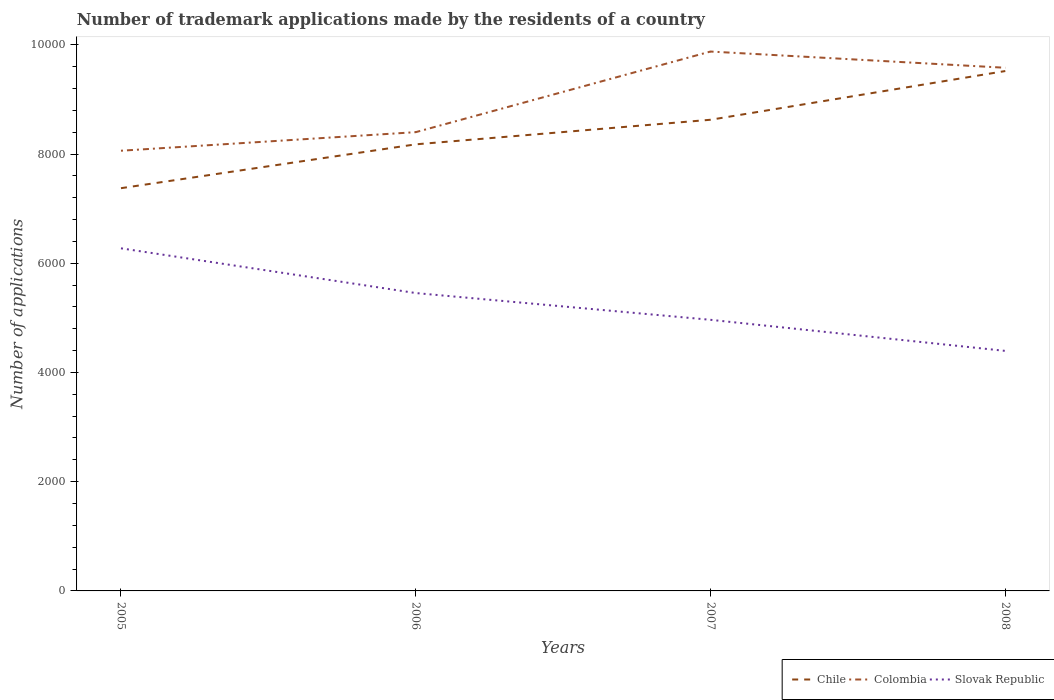Is the number of lines equal to the number of legend labels?
Your answer should be compact. Yes. Across all years, what is the maximum number of trademark applications made by the residents in Chile?
Keep it short and to the point. 7374. In which year was the number of trademark applications made by the residents in Colombia maximum?
Offer a terse response. 2005. What is the total number of trademark applications made by the residents in Chile in the graph?
Your response must be concise. -1342. What is the difference between the highest and the second highest number of trademark applications made by the residents in Colombia?
Give a very brief answer. 1816. What is the difference between the highest and the lowest number of trademark applications made by the residents in Colombia?
Provide a short and direct response. 2. Is the number of trademark applications made by the residents in Chile strictly greater than the number of trademark applications made by the residents in Slovak Republic over the years?
Give a very brief answer. No. What is the difference between two consecutive major ticks on the Y-axis?
Make the answer very short. 2000. Are the values on the major ticks of Y-axis written in scientific E-notation?
Make the answer very short. No. Does the graph contain any zero values?
Make the answer very short. No. Does the graph contain grids?
Your answer should be very brief. No. What is the title of the graph?
Make the answer very short. Number of trademark applications made by the residents of a country. Does "Nicaragua" appear as one of the legend labels in the graph?
Give a very brief answer. No. What is the label or title of the X-axis?
Make the answer very short. Years. What is the label or title of the Y-axis?
Provide a short and direct response. Number of applications. What is the Number of applications in Chile in 2005?
Keep it short and to the point. 7374. What is the Number of applications of Colombia in 2005?
Make the answer very short. 8060. What is the Number of applications in Slovak Republic in 2005?
Keep it short and to the point. 6273. What is the Number of applications in Chile in 2006?
Your answer should be compact. 8177. What is the Number of applications of Colombia in 2006?
Your response must be concise. 8400. What is the Number of applications in Slovak Republic in 2006?
Make the answer very short. 5454. What is the Number of applications in Chile in 2007?
Make the answer very short. 8627. What is the Number of applications in Colombia in 2007?
Give a very brief answer. 9876. What is the Number of applications in Slovak Republic in 2007?
Your answer should be compact. 4964. What is the Number of applications of Chile in 2008?
Offer a terse response. 9519. What is the Number of applications of Colombia in 2008?
Offer a terse response. 9579. What is the Number of applications in Slovak Republic in 2008?
Offer a terse response. 4395. Across all years, what is the maximum Number of applications of Chile?
Provide a succinct answer. 9519. Across all years, what is the maximum Number of applications in Colombia?
Your answer should be very brief. 9876. Across all years, what is the maximum Number of applications in Slovak Republic?
Offer a very short reply. 6273. Across all years, what is the minimum Number of applications in Chile?
Offer a terse response. 7374. Across all years, what is the minimum Number of applications of Colombia?
Your response must be concise. 8060. Across all years, what is the minimum Number of applications in Slovak Republic?
Your answer should be compact. 4395. What is the total Number of applications of Chile in the graph?
Provide a succinct answer. 3.37e+04. What is the total Number of applications in Colombia in the graph?
Your answer should be compact. 3.59e+04. What is the total Number of applications of Slovak Republic in the graph?
Make the answer very short. 2.11e+04. What is the difference between the Number of applications of Chile in 2005 and that in 2006?
Your response must be concise. -803. What is the difference between the Number of applications of Colombia in 2005 and that in 2006?
Ensure brevity in your answer.  -340. What is the difference between the Number of applications of Slovak Republic in 2005 and that in 2006?
Your response must be concise. 819. What is the difference between the Number of applications of Chile in 2005 and that in 2007?
Give a very brief answer. -1253. What is the difference between the Number of applications of Colombia in 2005 and that in 2007?
Offer a very short reply. -1816. What is the difference between the Number of applications of Slovak Republic in 2005 and that in 2007?
Make the answer very short. 1309. What is the difference between the Number of applications in Chile in 2005 and that in 2008?
Your answer should be very brief. -2145. What is the difference between the Number of applications of Colombia in 2005 and that in 2008?
Provide a short and direct response. -1519. What is the difference between the Number of applications of Slovak Republic in 2005 and that in 2008?
Provide a short and direct response. 1878. What is the difference between the Number of applications of Chile in 2006 and that in 2007?
Provide a short and direct response. -450. What is the difference between the Number of applications of Colombia in 2006 and that in 2007?
Your response must be concise. -1476. What is the difference between the Number of applications in Slovak Republic in 2006 and that in 2007?
Keep it short and to the point. 490. What is the difference between the Number of applications in Chile in 2006 and that in 2008?
Offer a very short reply. -1342. What is the difference between the Number of applications in Colombia in 2006 and that in 2008?
Keep it short and to the point. -1179. What is the difference between the Number of applications in Slovak Republic in 2006 and that in 2008?
Keep it short and to the point. 1059. What is the difference between the Number of applications of Chile in 2007 and that in 2008?
Provide a succinct answer. -892. What is the difference between the Number of applications of Colombia in 2007 and that in 2008?
Give a very brief answer. 297. What is the difference between the Number of applications of Slovak Republic in 2007 and that in 2008?
Give a very brief answer. 569. What is the difference between the Number of applications of Chile in 2005 and the Number of applications of Colombia in 2006?
Your response must be concise. -1026. What is the difference between the Number of applications in Chile in 2005 and the Number of applications in Slovak Republic in 2006?
Give a very brief answer. 1920. What is the difference between the Number of applications in Colombia in 2005 and the Number of applications in Slovak Republic in 2006?
Your answer should be very brief. 2606. What is the difference between the Number of applications of Chile in 2005 and the Number of applications of Colombia in 2007?
Offer a very short reply. -2502. What is the difference between the Number of applications in Chile in 2005 and the Number of applications in Slovak Republic in 2007?
Your answer should be compact. 2410. What is the difference between the Number of applications in Colombia in 2005 and the Number of applications in Slovak Republic in 2007?
Your response must be concise. 3096. What is the difference between the Number of applications of Chile in 2005 and the Number of applications of Colombia in 2008?
Offer a very short reply. -2205. What is the difference between the Number of applications in Chile in 2005 and the Number of applications in Slovak Republic in 2008?
Your answer should be compact. 2979. What is the difference between the Number of applications of Colombia in 2005 and the Number of applications of Slovak Republic in 2008?
Ensure brevity in your answer.  3665. What is the difference between the Number of applications of Chile in 2006 and the Number of applications of Colombia in 2007?
Offer a very short reply. -1699. What is the difference between the Number of applications in Chile in 2006 and the Number of applications in Slovak Republic in 2007?
Offer a very short reply. 3213. What is the difference between the Number of applications of Colombia in 2006 and the Number of applications of Slovak Republic in 2007?
Keep it short and to the point. 3436. What is the difference between the Number of applications of Chile in 2006 and the Number of applications of Colombia in 2008?
Your answer should be very brief. -1402. What is the difference between the Number of applications of Chile in 2006 and the Number of applications of Slovak Republic in 2008?
Offer a terse response. 3782. What is the difference between the Number of applications of Colombia in 2006 and the Number of applications of Slovak Republic in 2008?
Your answer should be compact. 4005. What is the difference between the Number of applications in Chile in 2007 and the Number of applications in Colombia in 2008?
Ensure brevity in your answer.  -952. What is the difference between the Number of applications in Chile in 2007 and the Number of applications in Slovak Republic in 2008?
Make the answer very short. 4232. What is the difference between the Number of applications of Colombia in 2007 and the Number of applications of Slovak Republic in 2008?
Your response must be concise. 5481. What is the average Number of applications in Chile per year?
Provide a short and direct response. 8424.25. What is the average Number of applications in Colombia per year?
Offer a very short reply. 8978.75. What is the average Number of applications in Slovak Republic per year?
Make the answer very short. 5271.5. In the year 2005, what is the difference between the Number of applications of Chile and Number of applications of Colombia?
Provide a short and direct response. -686. In the year 2005, what is the difference between the Number of applications of Chile and Number of applications of Slovak Republic?
Your answer should be very brief. 1101. In the year 2005, what is the difference between the Number of applications of Colombia and Number of applications of Slovak Republic?
Your response must be concise. 1787. In the year 2006, what is the difference between the Number of applications of Chile and Number of applications of Colombia?
Offer a terse response. -223. In the year 2006, what is the difference between the Number of applications of Chile and Number of applications of Slovak Republic?
Give a very brief answer. 2723. In the year 2006, what is the difference between the Number of applications in Colombia and Number of applications in Slovak Republic?
Make the answer very short. 2946. In the year 2007, what is the difference between the Number of applications in Chile and Number of applications in Colombia?
Provide a succinct answer. -1249. In the year 2007, what is the difference between the Number of applications in Chile and Number of applications in Slovak Republic?
Make the answer very short. 3663. In the year 2007, what is the difference between the Number of applications of Colombia and Number of applications of Slovak Republic?
Your answer should be compact. 4912. In the year 2008, what is the difference between the Number of applications of Chile and Number of applications of Colombia?
Keep it short and to the point. -60. In the year 2008, what is the difference between the Number of applications in Chile and Number of applications in Slovak Republic?
Offer a terse response. 5124. In the year 2008, what is the difference between the Number of applications of Colombia and Number of applications of Slovak Republic?
Offer a terse response. 5184. What is the ratio of the Number of applications of Chile in 2005 to that in 2006?
Make the answer very short. 0.9. What is the ratio of the Number of applications in Colombia in 2005 to that in 2006?
Give a very brief answer. 0.96. What is the ratio of the Number of applications of Slovak Republic in 2005 to that in 2006?
Provide a succinct answer. 1.15. What is the ratio of the Number of applications of Chile in 2005 to that in 2007?
Your answer should be very brief. 0.85. What is the ratio of the Number of applications of Colombia in 2005 to that in 2007?
Your response must be concise. 0.82. What is the ratio of the Number of applications of Slovak Republic in 2005 to that in 2007?
Keep it short and to the point. 1.26. What is the ratio of the Number of applications in Chile in 2005 to that in 2008?
Offer a very short reply. 0.77. What is the ratio of the Number of applications in Colombia in 2005 to that in 2008?
Offer a terse response. 0.84. What is the ratio of the Number of applications in Slovak Republic in 2005 to that in 2008?
Your answer should be compact. 1.43. What is the ratio of the Number of applications of Chile in 2006 to that in 2007?
Your response must be concise. 0.95. What is the ratio of the Number of applications in Colombia in 2006 to that in 2007?
Provide a succinct answer. 0.85. What is the ratio of the Number of applications of Slovak Republic in 2006 to that in 2007?
Your answer should be compact. 1.1. What is the ratio of the Number of applications of Chile in 2006 to that in 2008?
Your answer should be compact. 0.86. What is the ratio of the Number of applications in Colombia in 2006 to that in 2008?
Offer a terse response. 0.88. What is the ratio of the Number of applications in Slovak Republic in 2006 to that in 2008?
Give a very brief answer. 1.24. What is the ratio of the Number of applications of Chile in 2007 to that in 2008?
Provide a short and direct response. 0.91. What is the ratio of the Number of applications in Colombia in 2007 to that in 2008?
Give a very brief answer. 1.03. What is the ratio of the Number of applications of Slovak Republic in 2007 to that in 2008?
Make the answer very short. 1.13. What is the difference between the highest and the second highest Number of applications of Chile?
Provide a succinct answer. 892. What is the difference between the highest and the second highest Number of applications in Colombia?
Provide a succinct answer. 297. What is the difference between the highest and the second highest Number of applications in Slovak Republic?
Your response must be concise. 819. What is the difference between the highest and the lowest Number of applications in Chile?
Keep it short and to the point. 2145. What is the difference between the highest and the lowest Number of applications of Colombia?
Provide a short and direct response. 1816. What is the difference between the highest and the lowest Number of applications of Slovak Republic?
Ensure brevity in your answer.  1878. 